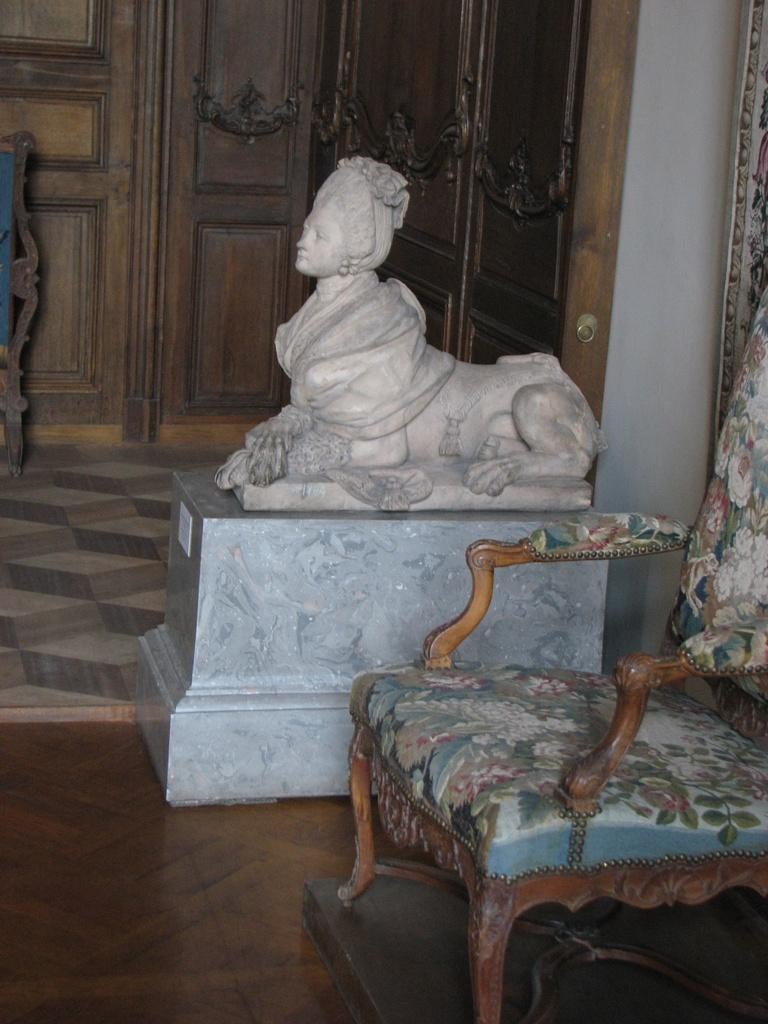What type of furniture is present in the image? There is a chair in the image. What other object can be seen in the image? There is a statue in the image. What material is the door in the background made of? The wooden door in the background is made of wood. What type of fan is visible in the image? There is no fan present in the image. 